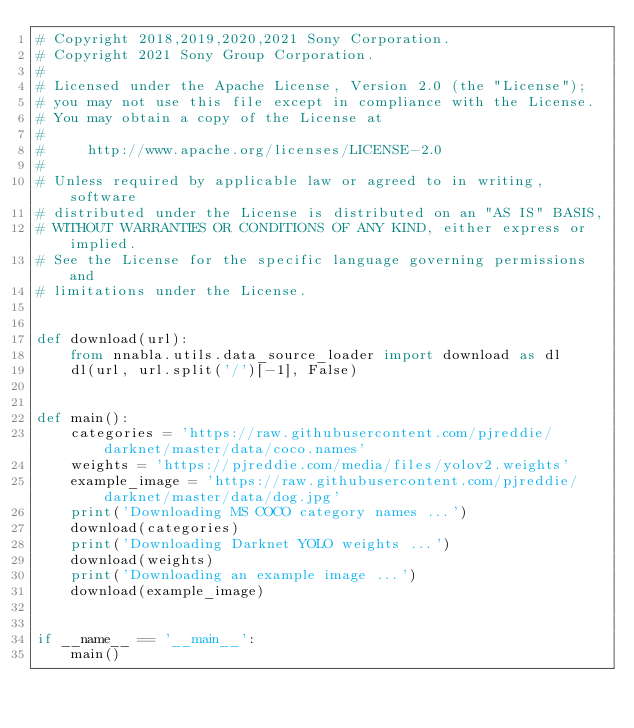Convert code to text. <code><loc_0><loc_0><loc_500><loc_500><_Python_># Copyright 2018,2019,2020,2021 Sony Corporation.
# Copyright 2021 Sony Group Corporation.
#
# Licensed under the Apache License, Version 2.0 (the "License");
# you may not use this file except in compliance with the License.
# You may obtain a copy of the License at
#
#     http://www.apache.org/licenses/LICENSE-2.0
#
# Unless required by applicable law or agreed to in writing, software
# distributed under the License is distributed on an "AS IS" BASIS,
# WITHOUT WARRANTIES OR CONDITIONS OF ANY KIND, either express or implied.
# See the License for the specific language governing permissions and
# limitations under the License.


def download(url):
    from nnabla.utils.data_source_loader import download as dl
    dl(url, url.split('/')[-1], False)


def main():
    categories = 'https://raw.githubusercontent.com/pjreddie/darknet/master/data/coco.names'
    weights = 'https://pjreddie.com/media/files/yolov2.weights'
    example_image = 'https://raw.githubusercontent.com/pjreddie/darknet/master/data/dog.jpg'
    print('Downloading MS COCO category names ...')
    download(categories)
    print('Downloading Darknet YOLO weights ...')
    download(weights)
    print('Downloading an example image ...')
    download(example_image)


if __name__ == '__main__':
    main()
</code> 